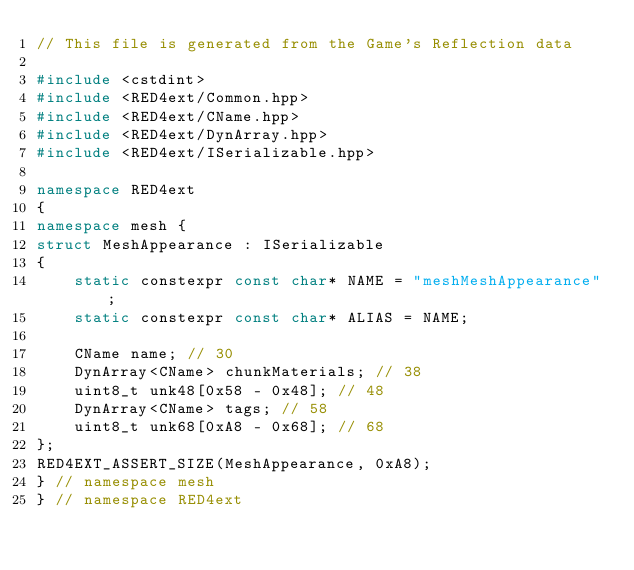<code> <loc_0><loc_0><loc_500><loc_500><_C++_>// This file is generated from the Game's Reflection data

#include <cstdint>
#include <RED4ext/Common.hpp>
#include <RED4ext/CName.hpp>
#include <RED4ext/DynArray.hpp>
#include <RED4ext/ISerializable.hpp>

namespace RED4ext
{
namespace mesh { 
struct MeshAppearance : ISerializable
{
    static constexpr const char* NAME = "meshMeshAppearance";
    static constexpr const char* ALIAS = NAME;

    CName name; // 30
    DynArray<CName> chunkMaterials; // 38
    uint8_t unk48[0x58 - 0x48]; // 48
    DynArray<CName> tags; // 58
    uint8_t unk68[0xA8 - 0x68]; // 68
};
RED4EXT_ASSERT_SIZE(MeshAppearance, 0xA8);
} // namespace mesh
} // namespace RED4ext
</code> 